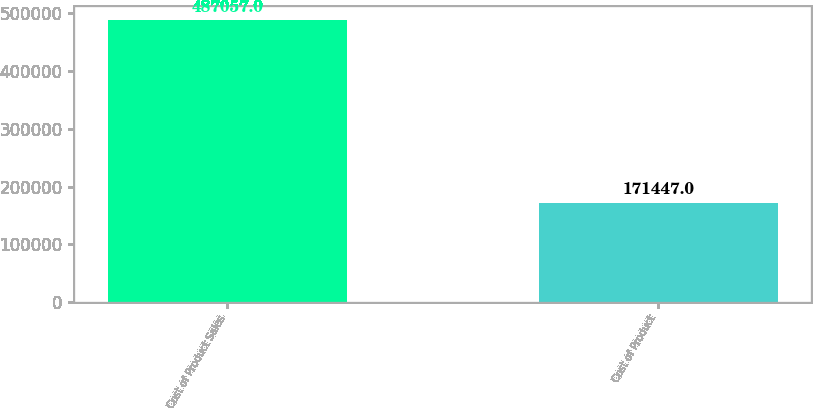Convert chart to OTSL. <chart><loc_0><loc_0><loc_500><loc_500><bar_chart><fcel>Cost of Product Sales<fcel>Cost of Product<nl><fcel>487057<fcel>171447<nl></chart> 